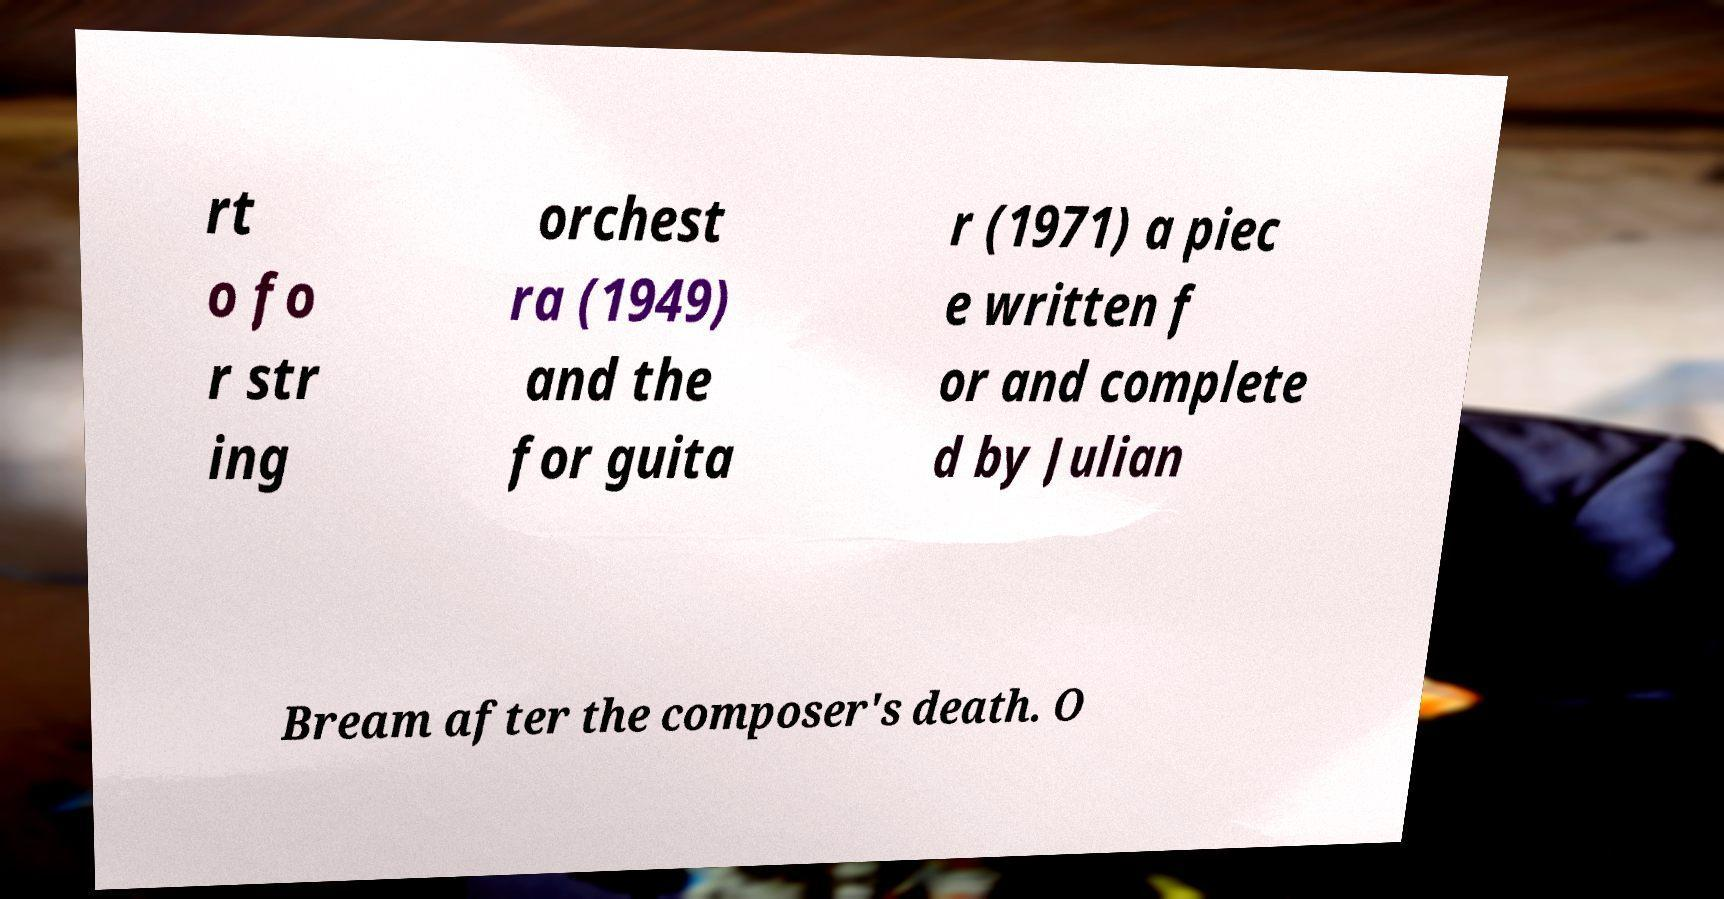What messages or text are displayed in this image? I need them in a readable, typed format. rt o fo r str ing orchest ra (1949) and the for guita r (1971) a piec e written f or and complete d by Julian Bream after the composer's death. O 